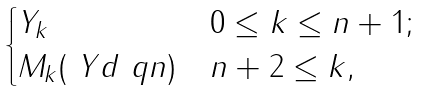Convert formula to latex. <formula><loc_0><loc_0><loc_500><loc_500>\begin{cases} Y _ { k } & 0 \leq k \leq n + 1 ; \\ M _ { k } ( \ Y d \ q { n } ) & n + 2 \leq k , \end{cases}</formula> 